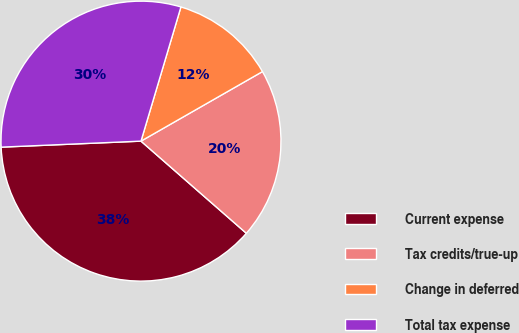Convert chart. <chart><loc_0><loc_0><loc_500><loc_500><pie_chart><fcel>Current expense<fcel>Tax credits/true-up<fcel>Change in deferred<fcel>Total tax expense<nl><fcel>37.88%<fcel>19.71%<fcel>12.12%<fcel>30.29%<nl></chart> 